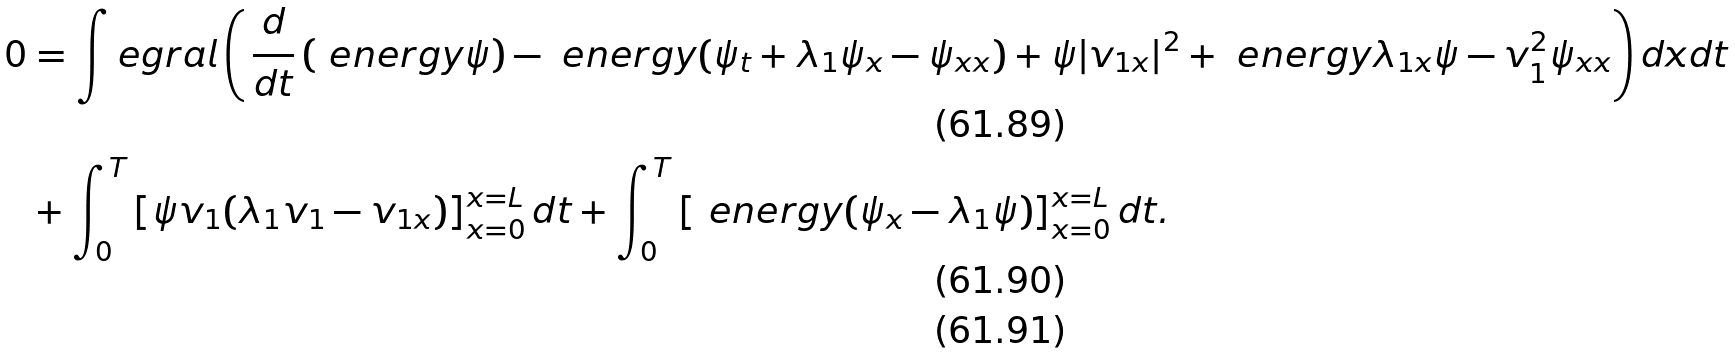<formula> <loc_0><loc_0><loc_500><loc_500>0 & = \int e g r a l \left ( \, \frac { d } { d t } \left ( \ e n e r g y \psi \right ) - \ e n e r g y ( \psi _ { t } + \lambda _ { 1 } \psi _ { x } - \psi _ { x x } ) + \psi | v _ { 1 x } | ^ { 2 } + \ e n e r g y \lambda _ { 1 x } \psi - v _ { 1 } ^ { 2 } \psi _ { x x } \right ) d x d t \\ & + \int _ { 0 } ^ { T } \left [ \psi v _ { 1 } ( \lambda _ { 1 } v _ { 1 } - v _ { 1 x } ) \right ] ^ { x = L } _ { x = 0 } d t + \int _ { 0 } ^ { T } \left [ \ e n e r g y ( \psi _ { x } - \lambda _ { 1 } \psi ) \right ] ^ { x = L } _ { x = 0 } d t . \\</formula> 